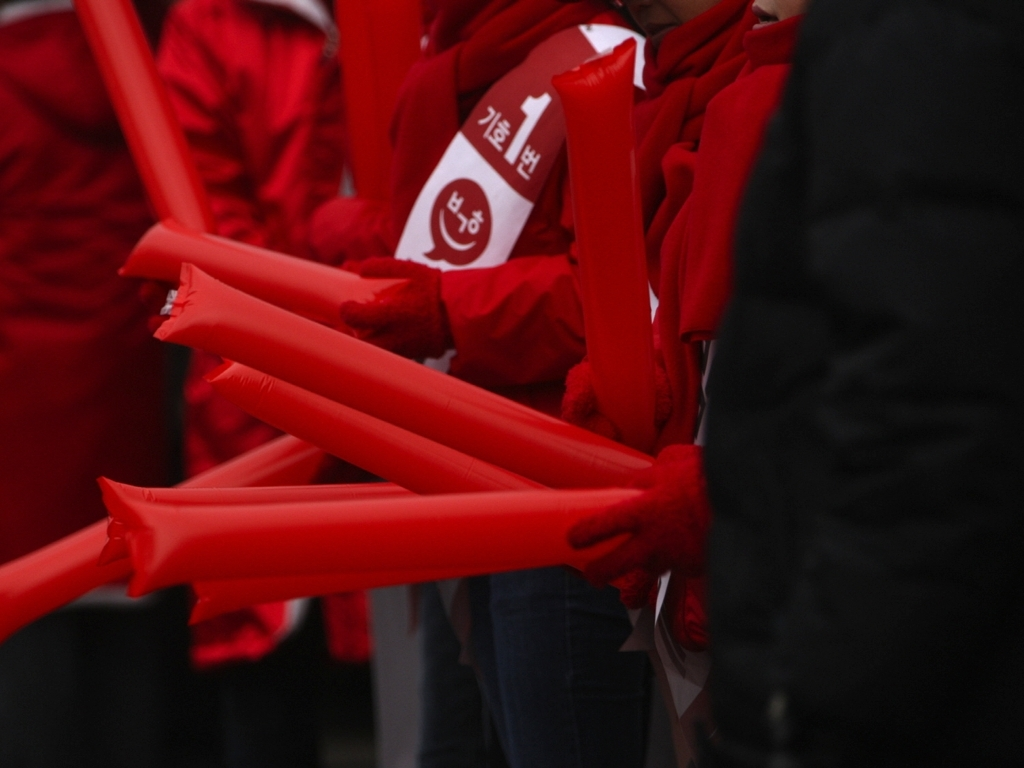What does the atmosphere implied by the red color and the way the objects are held convey to you? The dominant red color, typically associated with intensity, passion, or urgency, combined with how tightly the objects are gripped, conveys a sense of solidarity and determination among the participants. It gives off an impression of a unified purpose and strong communal involvement, possibly rallying for a cause or supporting a team with fervor. 